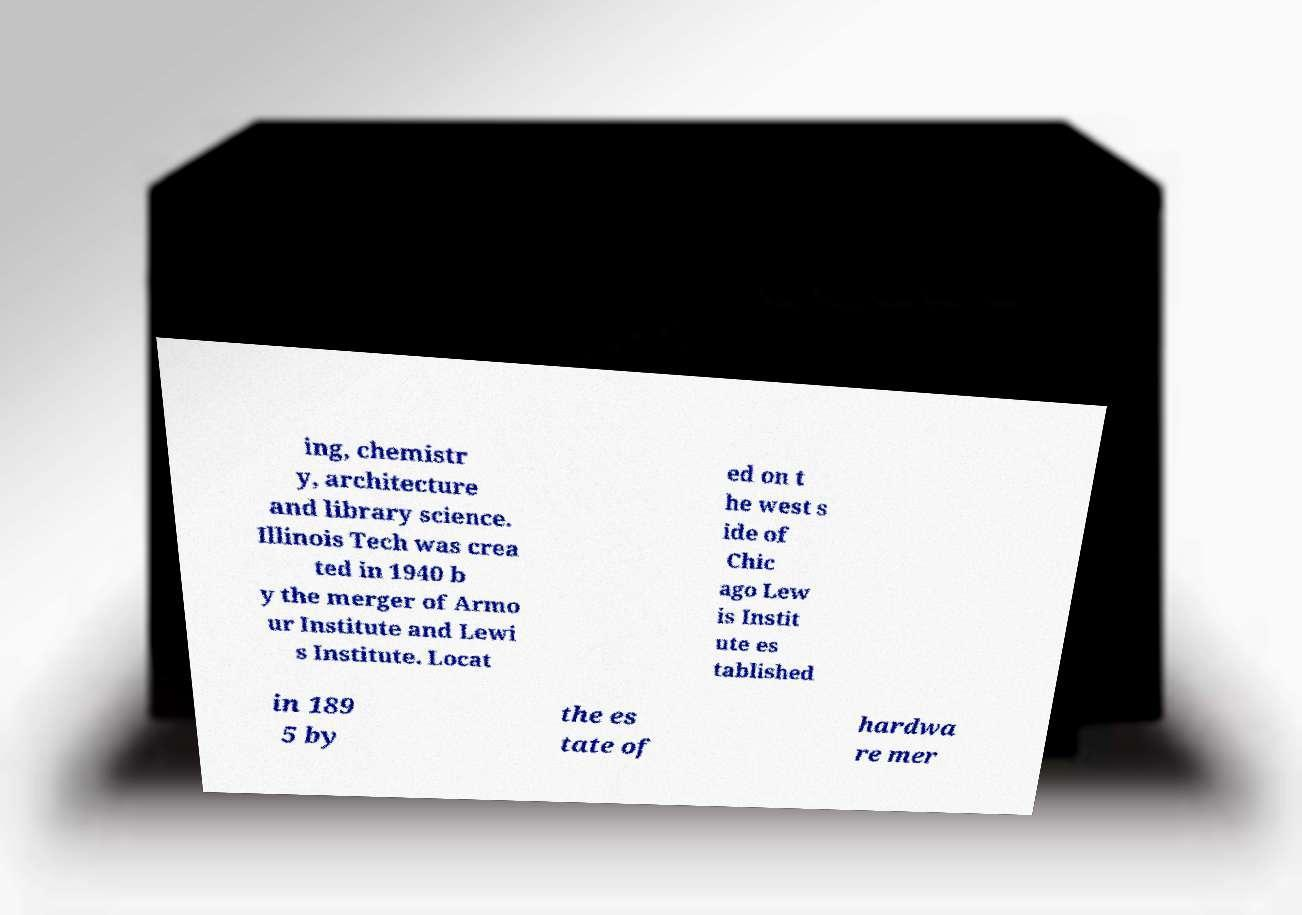Can you read and provide the text displayed in the image?This photo seems to have some interesting text. Can you extract and type it out for me? ing, chemistr y, architecture and library science. Illinois Tech was crea ted in 1940 b y the merger of Armo ur Institute and Lewi s Institute. Locat ed on t he west s ide of Chic ago Lew is Instit ute es tablished in 189 5 by the es tate of hardwa re mer 